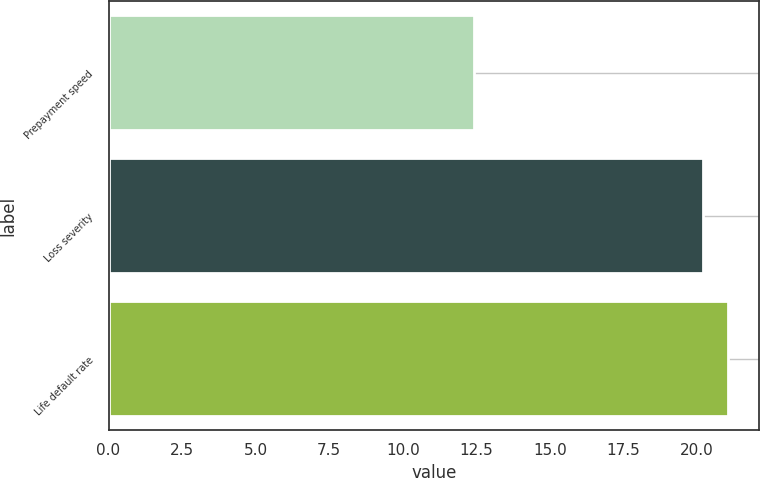<chart> <loc_0><loc_0><loc_500><loc_500><bar_chart><fcel>Prepayment speed<fcel>Loss severity<fcel>Life default rate<nl><fcel>12.4<fcel>20.2<fcel>21.05<nl></chart> 